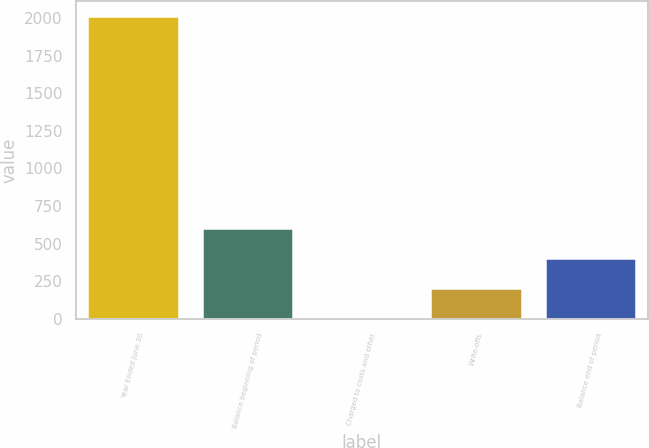Convert chart. <chart><loc_0><loc_0><loc_500><loc_500><bar_chart><fcel>Year Ended June 30<fcel>Balance beginning of period<fcel>Charged to costs and other<fcel>Write-offs<fcel>Balance end of period<nl><fcel>2013<fcel>606.7<fcel>4<fcel>204.9<fcel>405.8<nl></chart> 